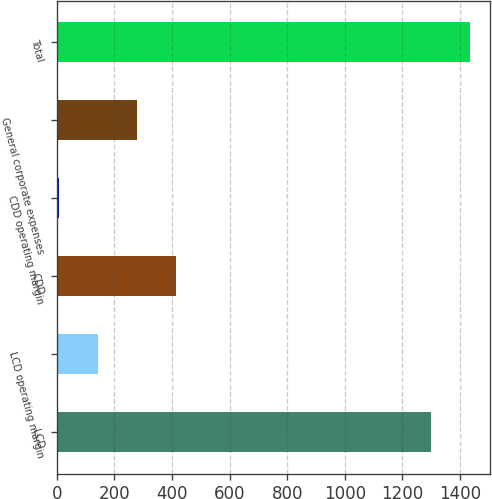Convert chart to OTSL. <chart><loc_0><loc_0><loc_500><loc_500><bar_chart><fcel>LCD<fcel>LCD operating margin<fcel>CDD<fcel>CDD operating margin<fcel>General corporate expenses<fcel>Total<nl><fcel>1298.6<fcel>142.54<fcel>414.02<fcel>6.8<fcel>278.28<fcel>1434.34<nl></chart> 